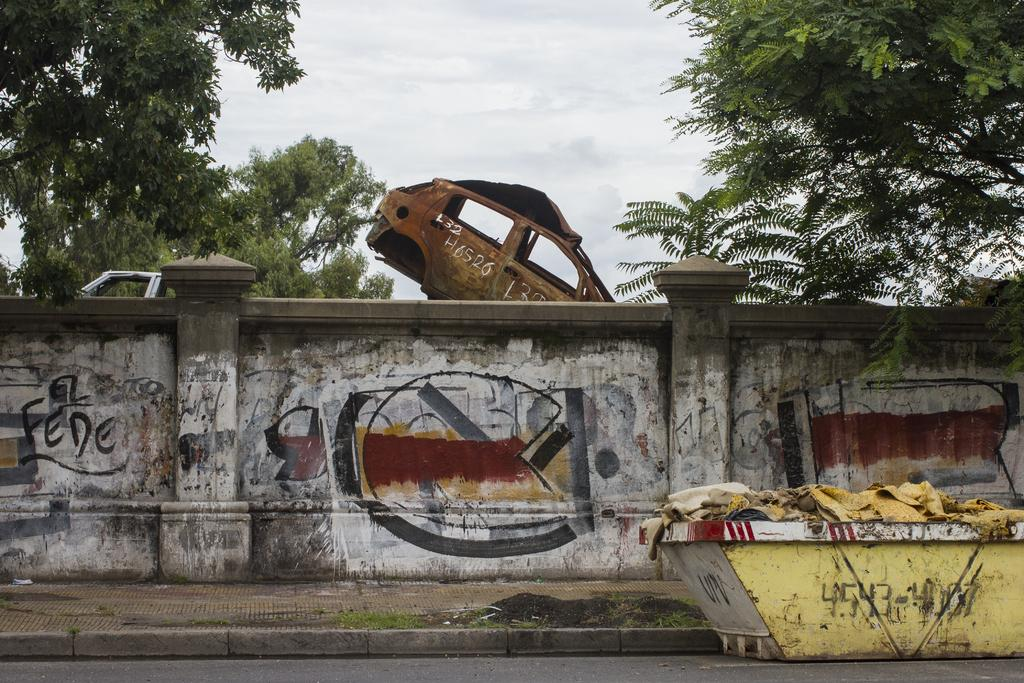What can be seen on the wall in the image? There are paintings on the wall in the image. What is located at the bottom of the image? There is a walkway, grass, a road, and containers at the bottom of the image. What is visible in the background of the image? There are vehicles, trees, and the sky visible in the background of the image. What type of songs can be heard playing in the background of the image? There is no audio or indication of music in the image, so it is not possible to determine what songs might be heard. Is there a trail visible in the image? There is no trail present in the image; it features a walkway, grass, a road, and containers at the bottom. What type of party is taking place in the image? There is no party or indication of a gathering in the image; it primarily features paintings on the wall, a walkway, grass, a road, containers, vehicles, trees, and the sky. 